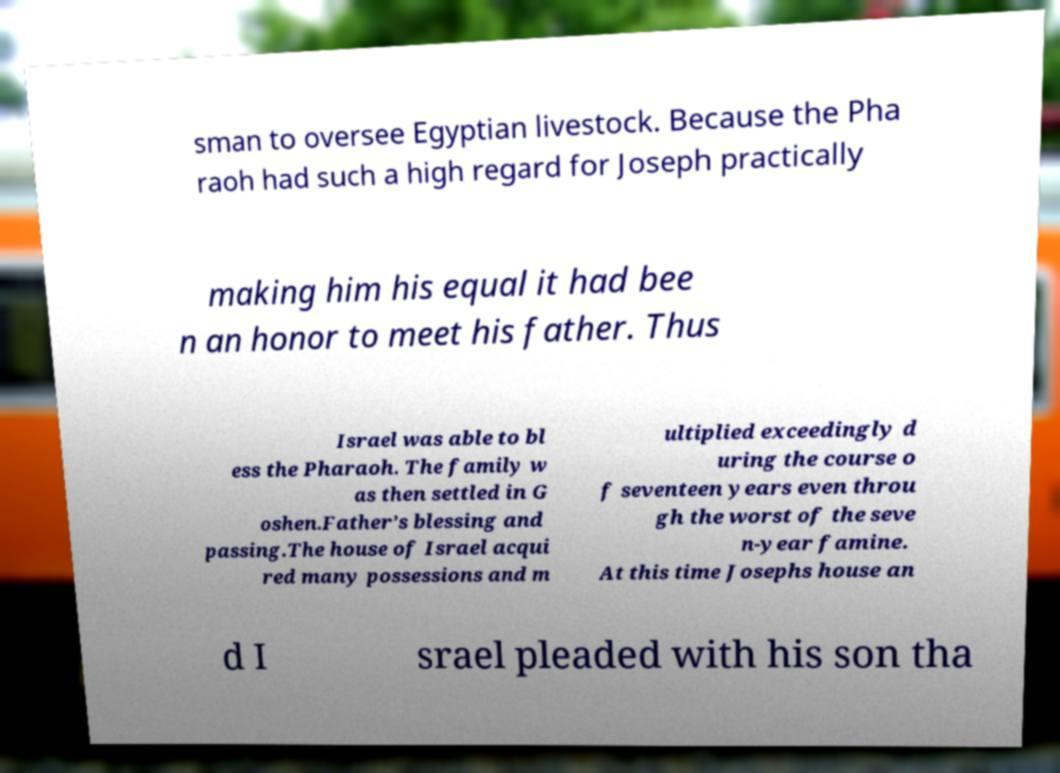Could you assist in decoding the text presented in this image and type it out clearly? sman to oversee Egyptian livestock. Because the Pha raoh had such a high regard for Joseph practically making him his equal it had bee n an honor to meet his father. Thus Israel was able to bl ess the Pharaoh. The family w as then settled in G oshen.Father’s blessing and passing.The house of Israel acqui red many possessions and m ultiplied exceedingly d uring the course o f seventeen years even throu gh the worst of the seve n-year famine. At this time Josephs house an d I srael pleaded with his son tha 